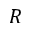Convert formula to latex. <formula><loc_0><loc_0><loc_500><loc_500>R</formula> 